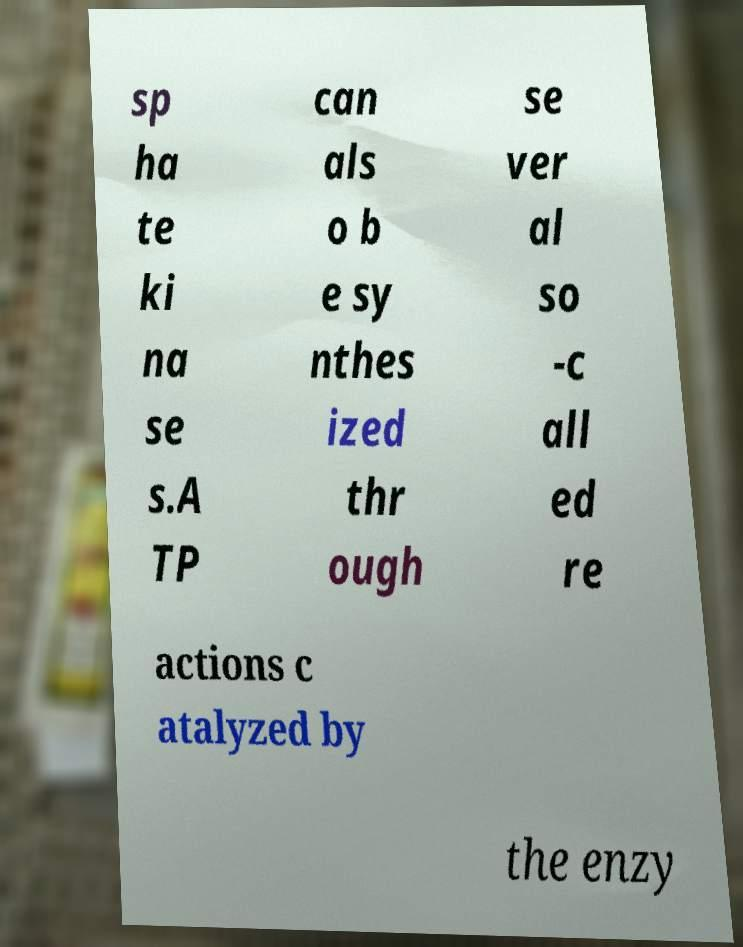For documentation purposes, I need the text within this image transcribed. Could you provide that? sp ha te ki na se s.A TP can als o b e sy nthes ized thr ough se ver al so -c all ed re actions c atalyzed by the enzy 